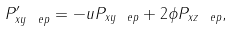<formula> <loc_0><loc_0><loc_500><loc_500>P _ { x y \ e p } ^ { \prime } = - u P _ { x y \ e p } + 2 \phi P _ { x z \ e p } ,</formula> 